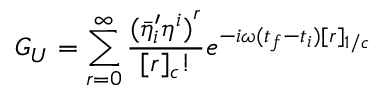<formula> <loc_0><loc_0><loc_500><loc_500>G _ { U } = \sum _ { r = 0 } ^ { \infty } \frac { { ( { { \bar { \eta } } ^ { \prime } } _ { i } { \eta } ^ { i } ) } ^ { r } } { [ r ] _ { c } ! } e ^ { - i \omega ( t _ { f } - t _ { i } ) [ r ] _ { 1 / c } }</formula> 